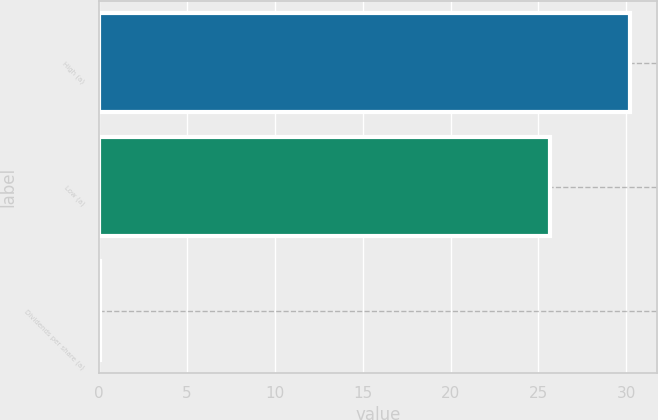Convert chart. <chart><loc_0><loc_0><loc_500><loc_500><bar_chart><fcel>High (a)<fcel>Low (a)<fcel>Dividends per share (a)<nl><fcel>30.24<fcel>25.68<fcel>0.05<nl></chart> 